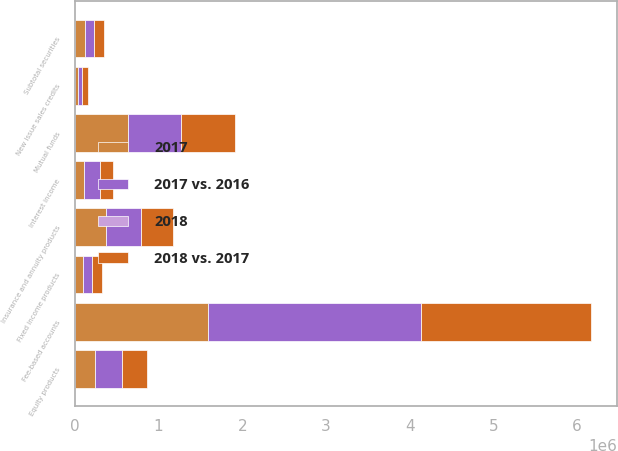<chart> <loc_0><loc_0><loc_500><loc_500><stacked_bar_chart><ecel><fcel>Fee-based accounts<fcel>Mutual funds<fcel>Insurance and annuity products<fcel>Equity products<fcel>Fixed income products<fcel>New issue sales credits<fcel>Subtotal securities<fcel>Interest income<nl><fcel>2017 vs. 2016<fcel>2.54034e+06<fcel>641603<fcel>413591<fcel>325514<fcel>112509<fcel>47200<fcel>118062<fcel>193105<nl><fcel>2018 vs. 2017<fcel>2.04084e+06<fcel>646614<fcel>385493<fcel>303015<fcel>118062<fcel>72281<fcel>118062<fcel>152711<nl><fcel>2017<fcel>1.58912e+06<fcel>631102<fcel>377329<fcel>240855<fcel>95908<fcel>44088<fcel>118062<fcel>107281<nl><fcel>2018<fcel>24<fcel>1<fcel>7<fcel>7<fcel>5<fcel>35<fcel>14<fcel>26<nl></chart> 